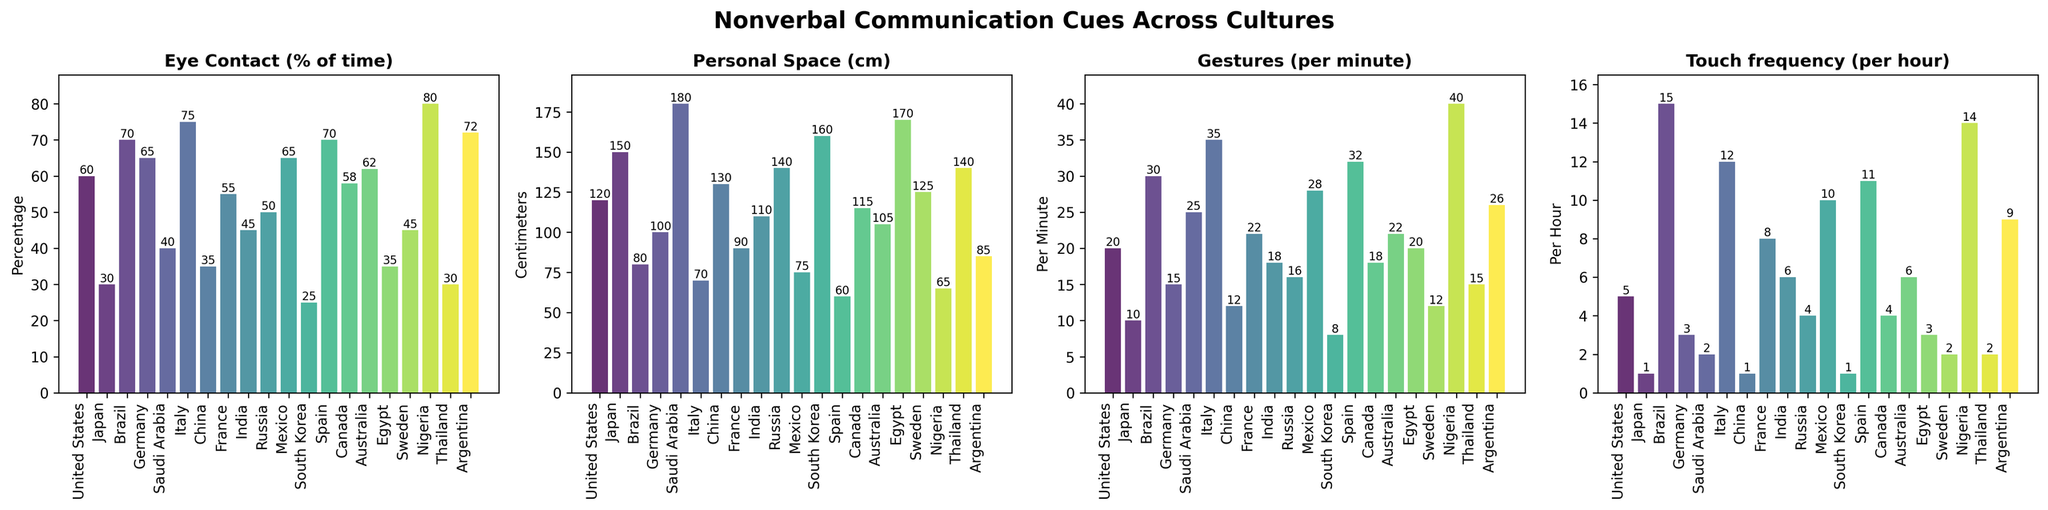Which country has the highest percentage of eye contact? To find the country with the highest percentage of eye contact, look for the tallest bar in the "Eye Contact (% of time)" subplot. The country corresponding to this bar is Nigeria.
Answer: Nigeria What is the difference in personal space between the United States and Japan? Find the bars for the United States and Japan in the "Personal Space (cm)" subplot. The United States has 120 cm and Japan has 150 cm, so the difference is 150 - 120 = 30 cm.
Answer: 30 cm Which two countries have the same touch frequency? In the "Touch frequency (per hour)" subplot, identify the bars with the same height. Canada and Russia both have 4 touches per hour.
Answer: Canada and Russia What is the average number of gestures per minute across all cultures? Add the values of "Gestures (per minute)" for all countries and divide by the total number of countries (19). The sum is 20 + 10 + 30 + 15 + 25 + 35 + 12 + 22 + 18 + 16 + 28 + 8 + 32 + 18 + 22 + 20 + 12 + 40 + 15 + 26 = 394. The average is 394 / 19 ≈ 20.74.
Answer: 20.74 Which culture has the least personal space? In the "Personal Space (cm)" subplot, identify the shortest bar. Italy has the shortest bar at 70 cm.
Answer: Italy How does the percentage of eye contact in the United States compare to that in Japan? In the "Eye Contact (% of time)" subplot, locate the bars for the United States and Japan. The United States has 60%, and Japan has 30%. The percentage of eye contact in the United States is higher than in Japan.
Answer: United States has higher eye contact Which country has a higher number of gestures per minute, France or Australia? Compare the heights of the bars for France and Australia in the "Gestures (per minute)" subplot. France has 22 gestures per minute, and Australia has 22 gestures per minute.
Answer: France and Australia What is the sum of the touch frequencies per hour for Mexico and India? Look at the "Touch frequency (per hour)" subplot and add the values for Mexico (10) and India (6). The sum is 10 + 6 = 16.
Answer: 16 Which countries have an eye contact percentage greater than 65%? In the "Eye Contact (% of time)" subplot, identify bars taller than the 65% mark. These countries are Italy, Brazil, Spain, and Nigeria.
Answer: Italy, Brazil, Spain, and Nigeria What is the range of personal space in centimeters across all cultures? Identify the maximum and minimum values in the "Personal Space (cm)" subplot. The maximum is 180 cm (Saudi Arabia), and the minimum is 60 cm (Spain). The range is 180 - 60 = 120 cm.
Answer: 120 cm 